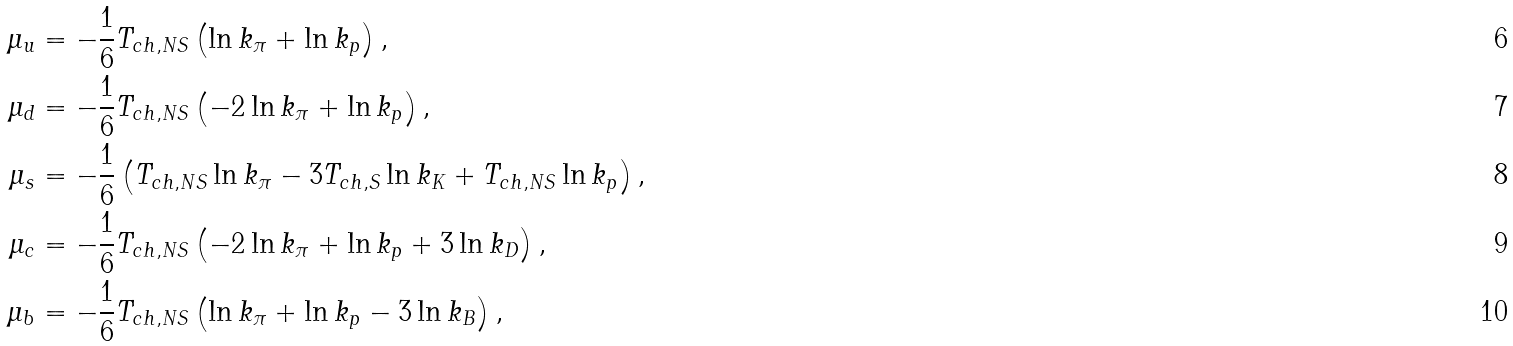Convert formula to latex. <formula><loc_0><loc_0><loc_500><loc_500>\mu _ { u } & = - \frac { 1 } { 6 } T _ { c h , N S } \left ( \ln k _ { \pi } + \ln k _ { p } \right ) , \\ \mu _ { d } & = - \frac { 1 } { 6 } T _ { c h , N S } \left ( - 2 \ln k _ { \pi } + \ln k _ { p } \right ) , \\ \mu _ { s } & = - \frac { 1 } { 6 } \left ( T _ { c h , N S } \ln k _ { \pi } - 3 T _ { c h , S } \ln k _ { K } + T _ { c h , N S } \ln k _ { p } \right ) , \\ \mu _ { c } & = - \frac { 1 } { 6 } T _ { c h , N S } \left ( - 2 \ln k _ { \pi } + \ln k _ { p } + 3 \ln k _ { D } \right ) , \\ \mu _ { b } & = - \frac { 1 } { 6 } T _ { c h , N S } \left ( \ln k _ { \pi } + \ln k _ { p } - 3 \ln k _ { B } \right ) ,</formula> 